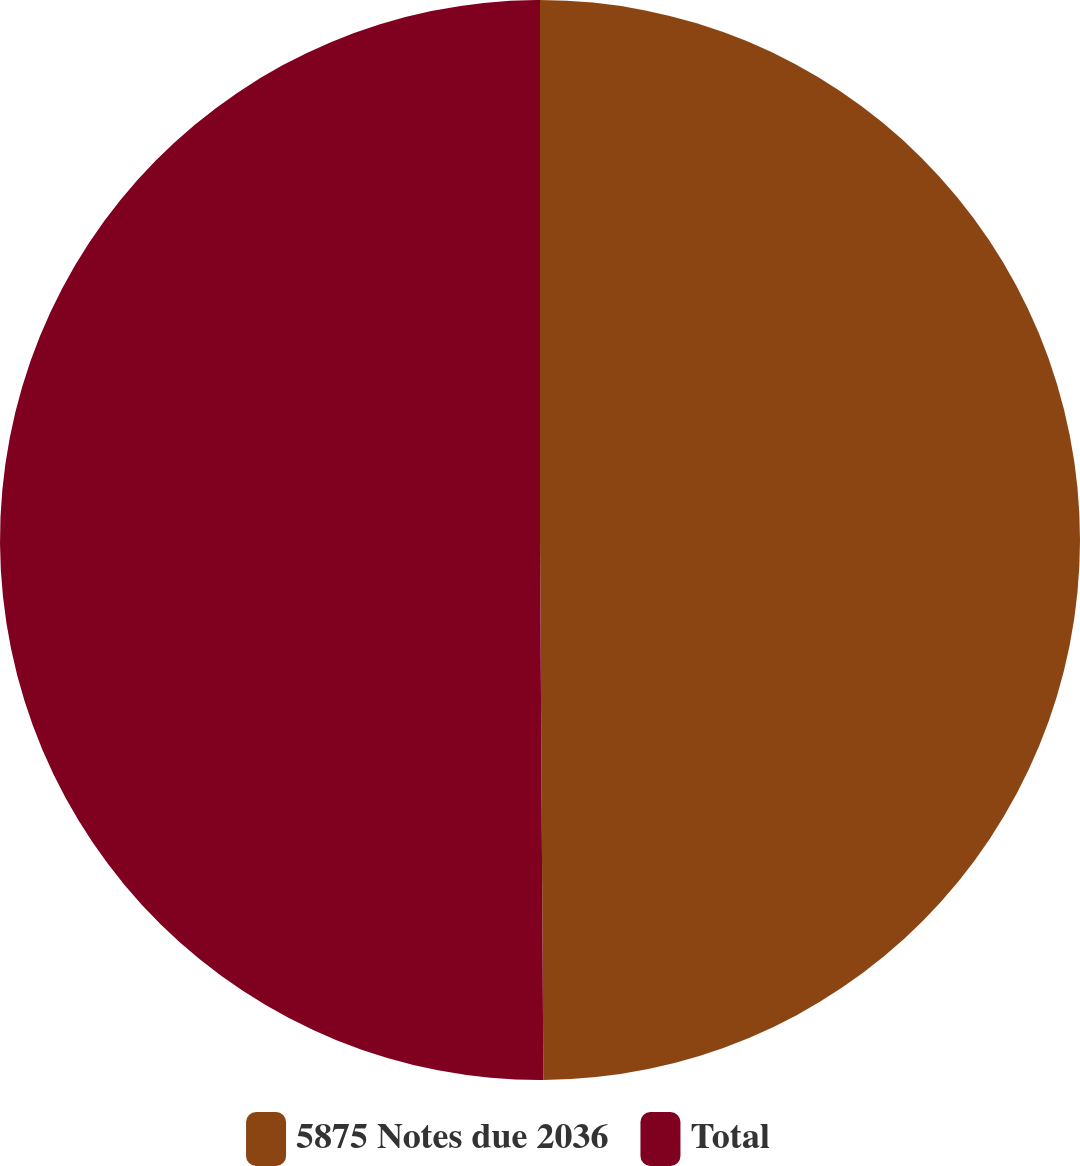Convert chart. <chart><loc_0><loc_0><loc_500><loc_500><pie_chart><fcel>5875 Notes due 2036<fcel>Total<nl><fcel>49.9%<fcel>50.1%<nl></chart> 